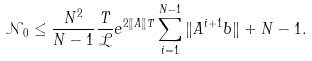Convert formula to latex. <formula><loc_0><loc_0><loc_500><loc_500>\mathcal { N } _ { 0 } \leq \frac { N ^ { 2 } } { N - 1 } \frac { T } { \mathcal { L } } e ^ { 2 \| A \| T } \sum _ { i = 1 } ^ { N - 1 } \| A ^ { i + 1 } b \| + N - 1 .</formula> 